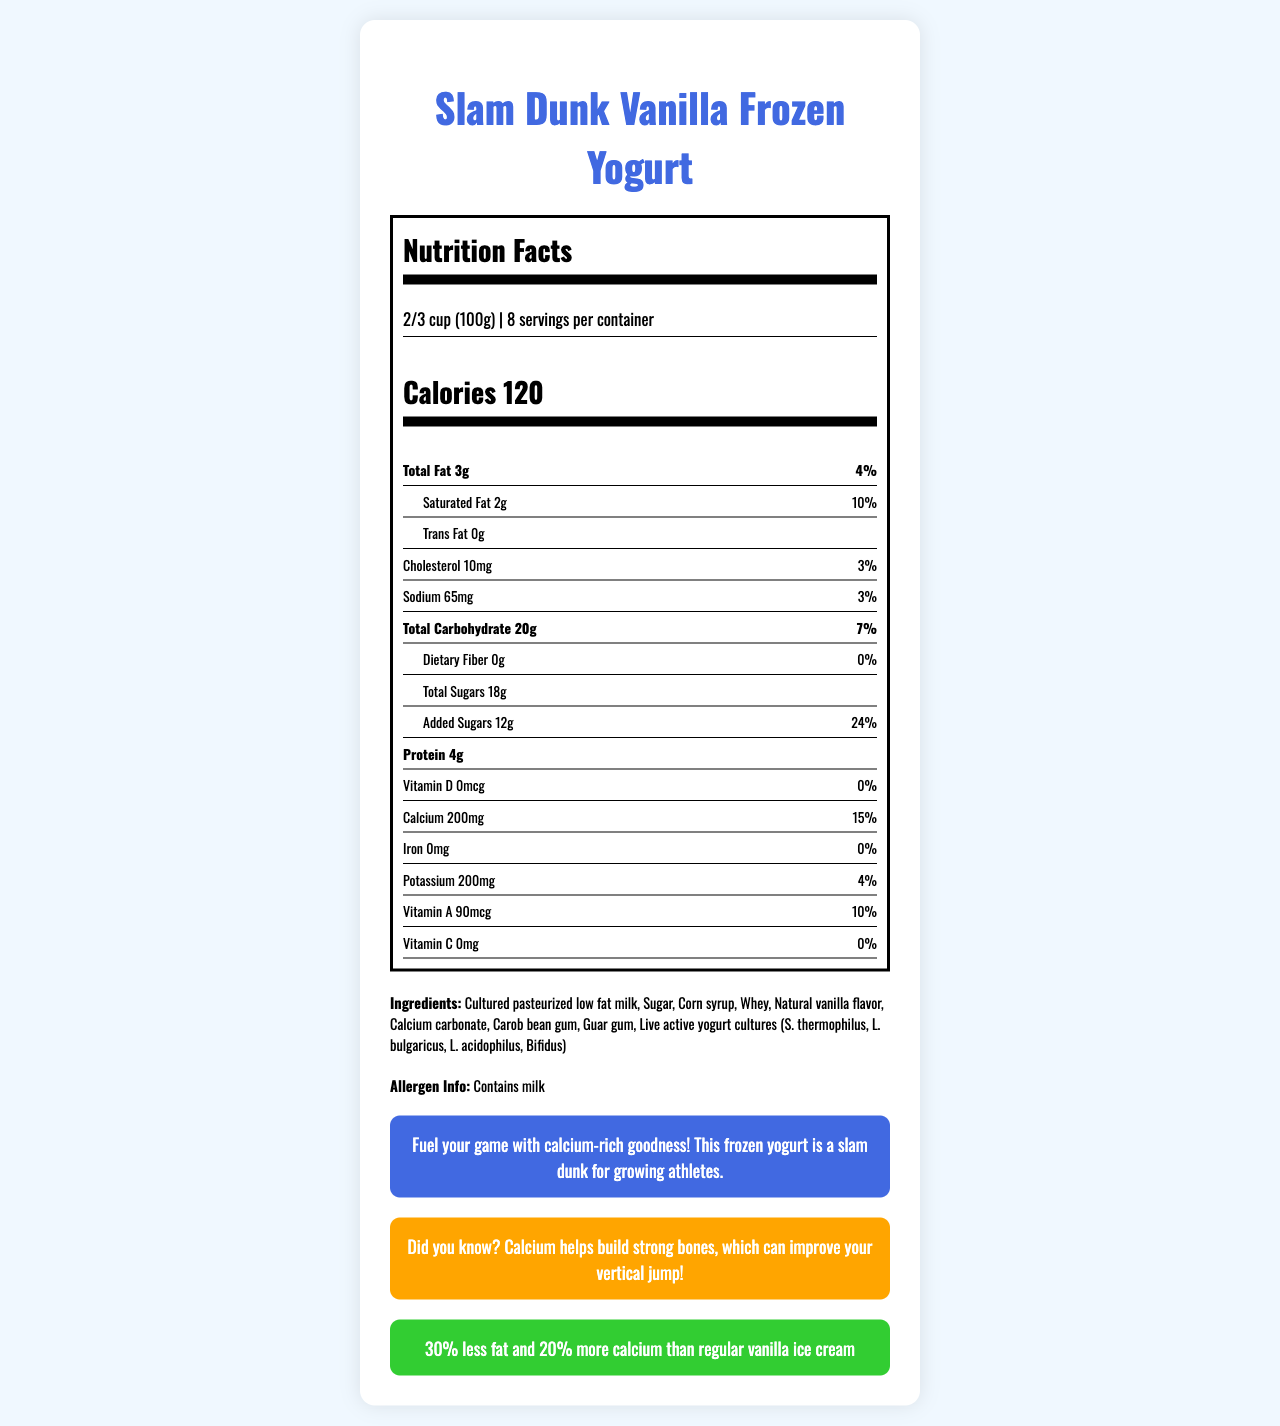what is the serving size? The serving size is indicated at the top of the nutrition facts section of the document.
Answer: 2/3 cup (100g) how many servings are in the container? This information is listed right below the serving size on the nutrition label.
Answer: 8 how many calories are in one serving? The number of calories per serving is prominently displayed in the nutrition label.
Answer: 120 what is the total fat content per serving? The total fat content per serving is indicated in the nutrition facts under the "Total Fat" category.
Answer: 3g what is the daily value percentage for calcium? The daily value percentage for calcium is listed under the calcium section of the nutrition facts.
Answer: 15% which ingredient is listed first? A. Sugar B. Corn syrup C. Cultured pasteurized low fat milk D. Natural vanilla flavor Cultured pasteurized low fat milk is shown as the first ingredient in the ingredients list.
Answer: C what are the live active yogurt cultures included? A. L. casei, L. rhamnosus, L. reuteri B. S. thermophilus, L. bulgaricus, L. acidophilus, Bifidus C. B. lactis, S. salivarius, L. plantarum D. L. rhamnosus, L. johnsonii, B. breve The specific live cultures included are S. thermophilus, L. bulgaricus, L. acidophilus, and Bifidus.
Answer: B does this product contain any allergens? The allergen information states "Contains milk."
Answer: Yes does this product contain trans fat? The nutrition label indicates 0g of trans fat.
Answer: No summarize the main message of the coach's statement. The coach's message emphasizes the importance of calcium for growing athletes and promoting this frozen yogurt as a good source of it.
Answer: The coach encourages athletes to fuel up with this calcium-rich yogurt for better performance. what is the comparison made between Slam Dunk Vanilla Frozen Yogurt and regular vanilla ice cream? The comparison states that the yogurt has 30% less fat and 20% more calcium than regular vanilla ice cream.
Answer: 30% less fat and 20% more calcium how much added sugar is in one serving? The amount of added sugars per serving is listed in the nutrition facts.
Answer: 12g what is the primary benefit related to basketball mentioned in the document? The basketball fact mentions that calcium helps build strong bones, which can improve vertical jump.
Answer: Improved vertical jump due to strong bones how much vitamin D does a serving provide? The amount of vitamin D per serving is listed as 0mcg in the nutrition facts.
Answer: 0mcg what is the daily value percentage for added sugars? The daily value percentage for added sugars is provided in the nutrition facts.
Answer: 24% can you determine the manufacturing process from this document? The document does not contain any information about the manufacturing process of the product.
Answer: Not enough information 